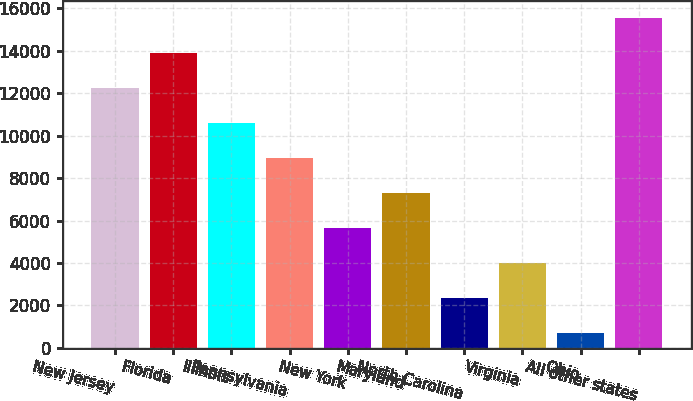<chart> <loc_0><loc_0><loc_500><loc_500><bar_chart><fcel>New Jersey<fcel>Florida<fcel>Illinois<fcel>Pennsylvania<fcel>New York<fcel>Maryland<fcel>North Carolina<fcel>Virginia<fcel>Ohio<fcel>All other states<nl><fcel>12253.6<fcel>13906.4<fcel>10600.8<fcel>8948<fcel>5642.4<fcel>7295.2<fcel>2336.8<fcel>3989.6<fcel>684<fcel>15559.2<nl></chart> 